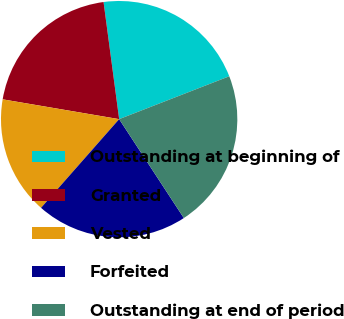<chart> <loc_0><loc_0><loc_500><loc_500><pie_chart><fcel>Outstanding at beginning of<fcel>Granted<fcel>Vested<fcel>Forfeited<fcel>Outstanding at end of period<nl><fcel>21.2%<fcel>20.21%<fcel>16.19%<fcel>20.71%<fcel>21.69%<nl></chart> 